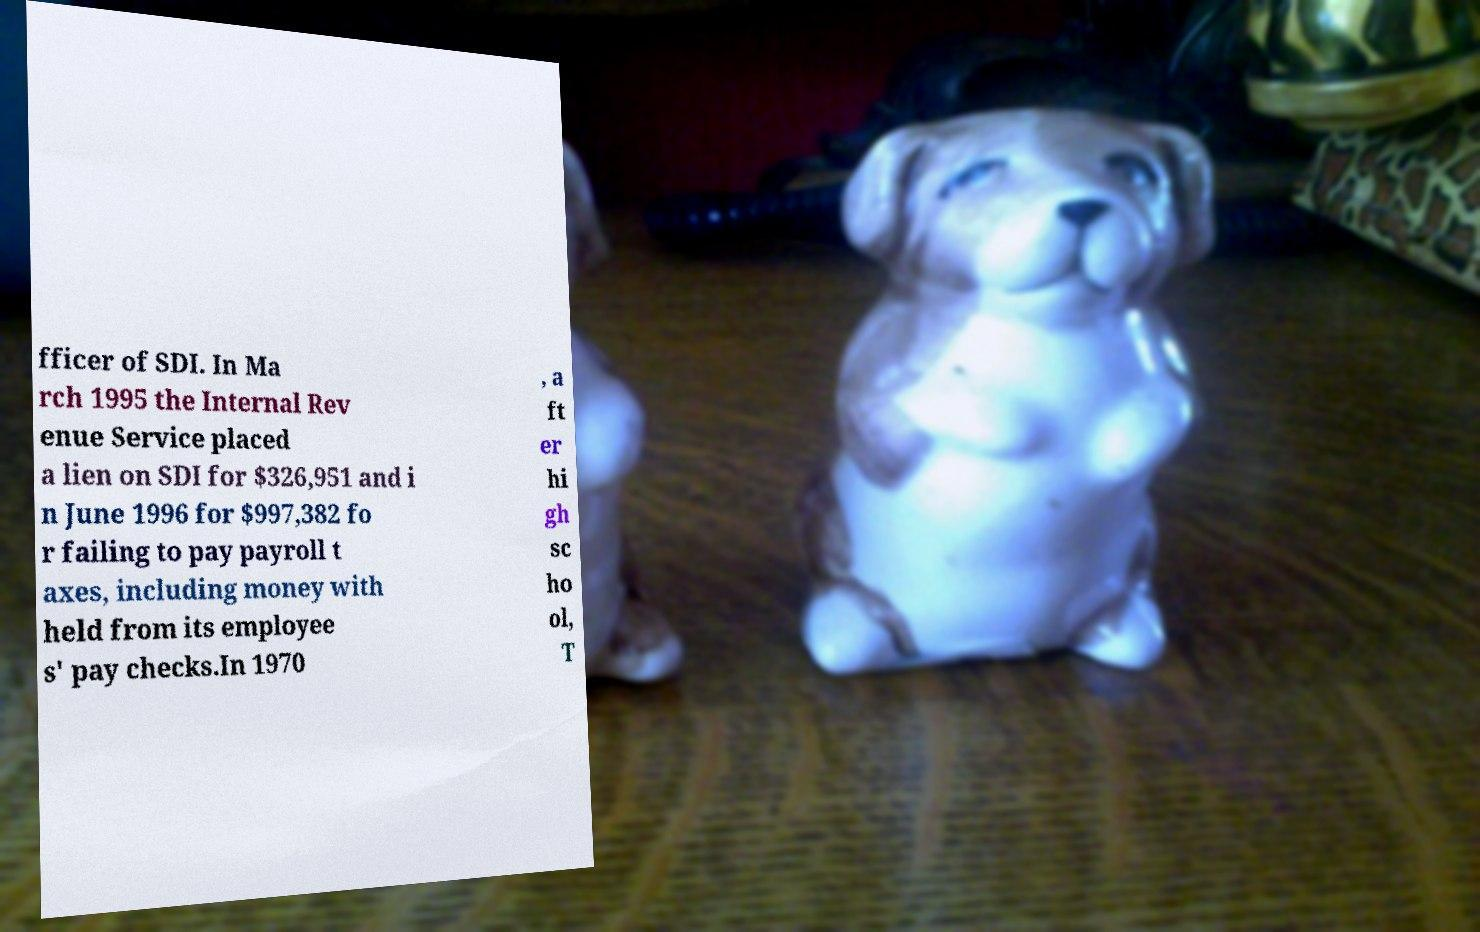Could you extract and type out the text from this image? fficer of SDI. In Ma rch 1995 the Internal Rev enue Service placed a lien on SDI for $326,951 and i n June 1996 for $997,382 fo r failing to pay payroll t axes, including money with held from its employee s' pay checks.In 1970 , a ft er hi gh sc ho ol, T 